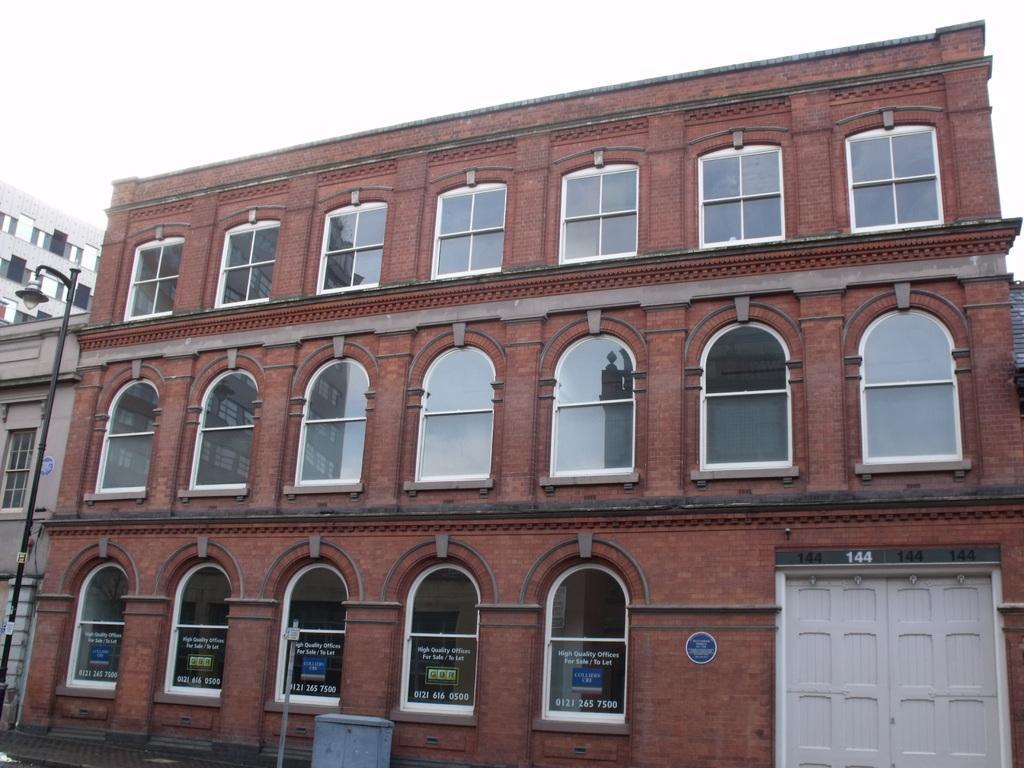Can you describe this image briefly? In this image in the front there are poles and there is a bin. In the background there are buildings and there is a door which is white in colour. 